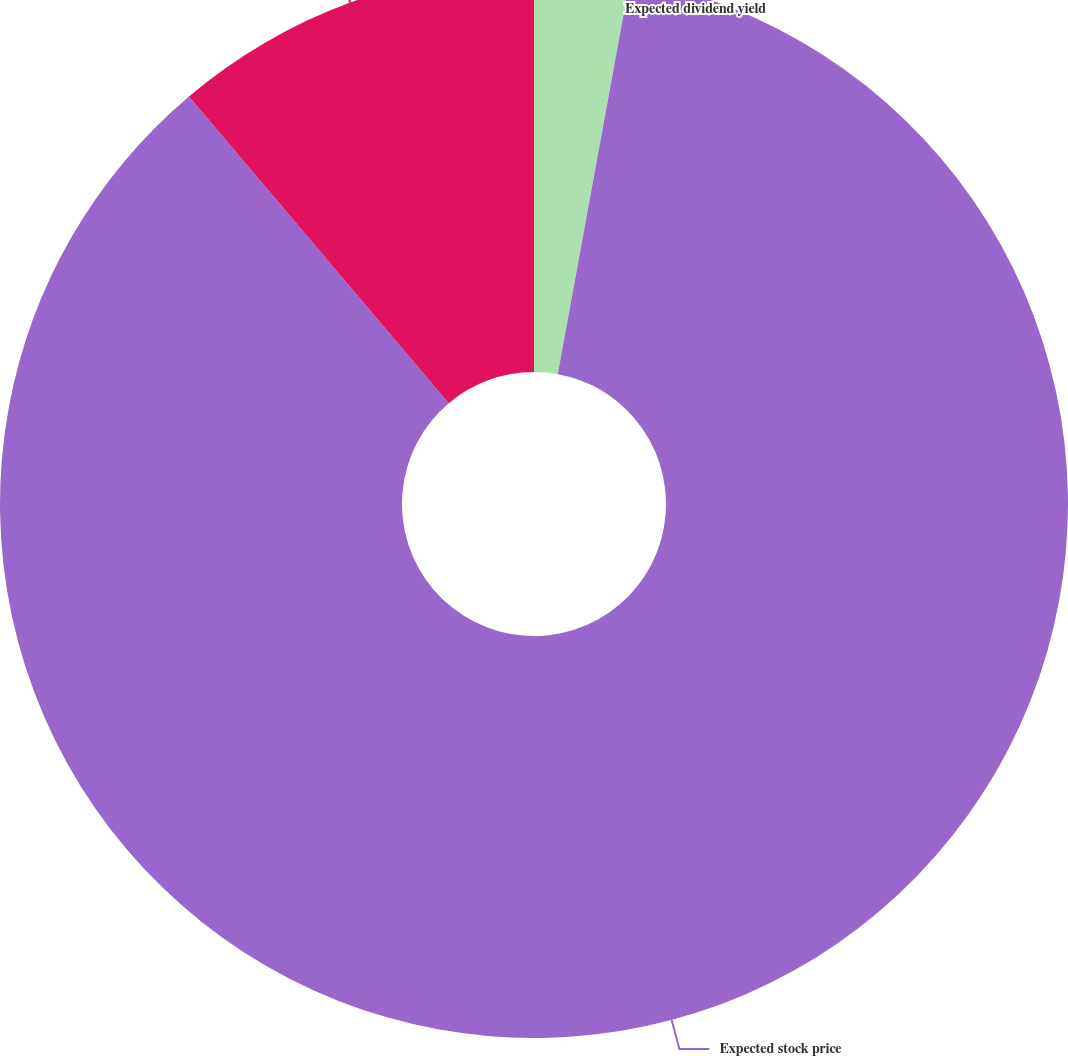Convert chart. <chart><loc_0><loc_0><loc_500><loc_500><pie_chart><fcel>Expected dividend yield<fcel>Expected stock price<fcel>Risk-free interest rate<nl><fcel>2.88%<fcel>85.94%<fcel>11.18%<nl></chart> 